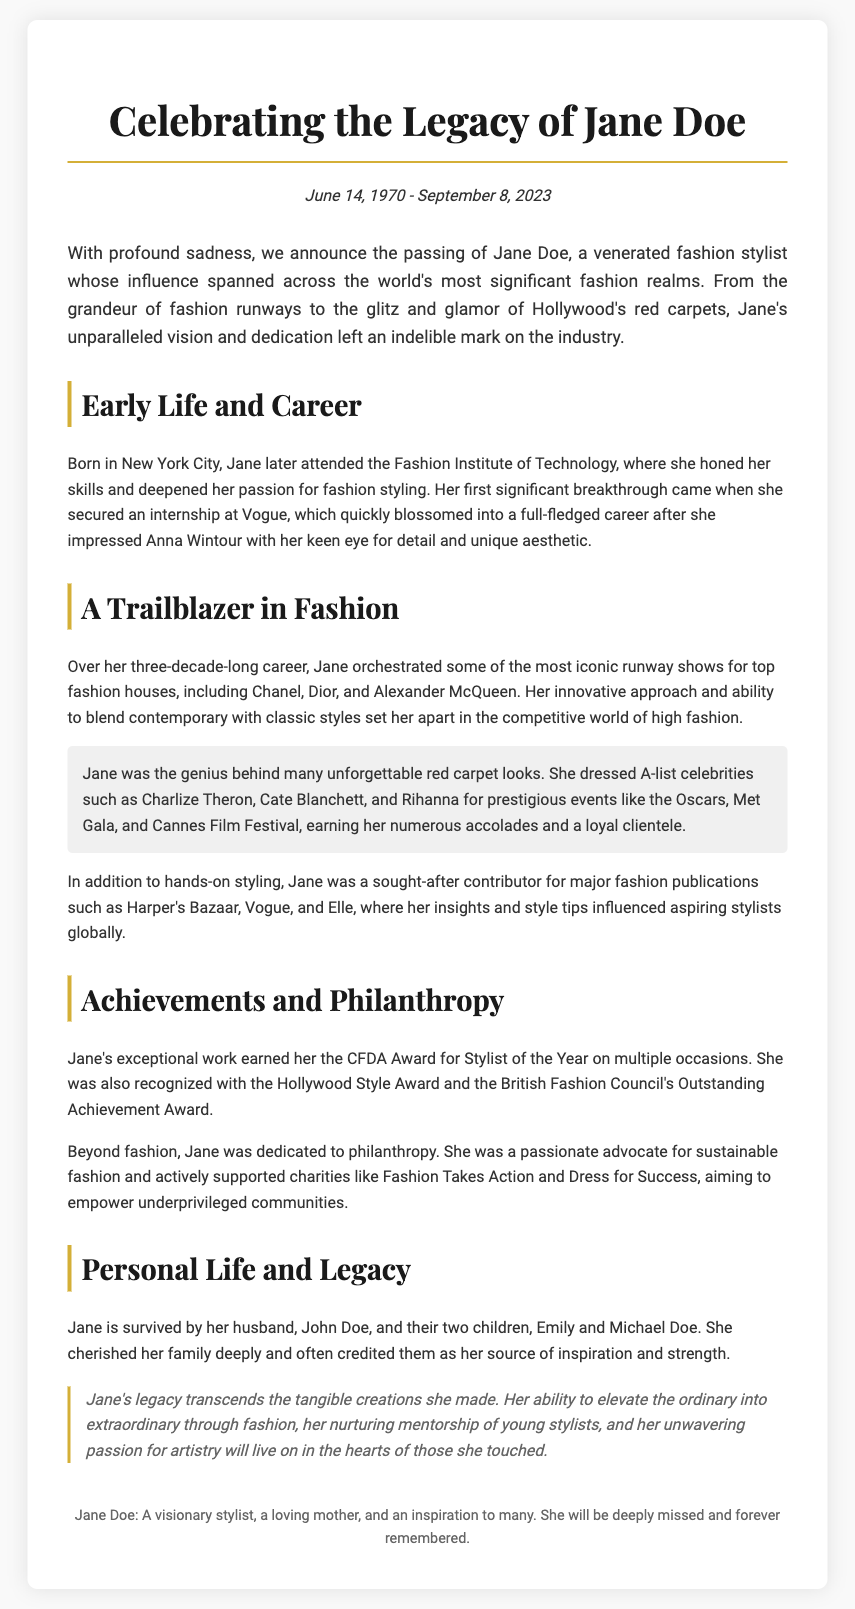What were the birth and death dates of Jane Doe? The document states that Jane Doe was born on June 14, 1970, and passed away on September 8, 2023.
Answer: June 14, 1970 - September 8, 2023 Where did Jane Doe grow up? The document indicates that Jane Doe was born in New York City.
Answer: New York City What notable fashion event did Jane dress A-list celebrities for? The document mentions the Oscars as a prestigious event where Jane styled celebrities.
Answer: Oscars How many children did Jane Doe have? The document states that Jane is survived by two children.
Answer: Two What awards did Jane Doe receive for her styling work? The document lists the CFDA Award for Stylist of the Year as one of Jane's achievements.
Answer: CFDA Award Which fashion institute did Jane attend? According to the document, Jane attended the Fashion Institute of Technology.
Answer: Fashion Institute of Technology What was Jane's profession? The document describes Jane Doe as a fashion stylist.
Answer: Fashion stylist What cause did Jane advocate for in her philanthropy efforts? The document mentions that Jane was a passionate advocate for sustainable fashion.
Answer: Sustainable fashion What legacy did Jane Doe leave behind according to the document? The document reflects on Jane's ability to elevate the ordinary into extraordinary through fashion as part of her legacy.
Answer: Elevating the ordinary into extraordinary 